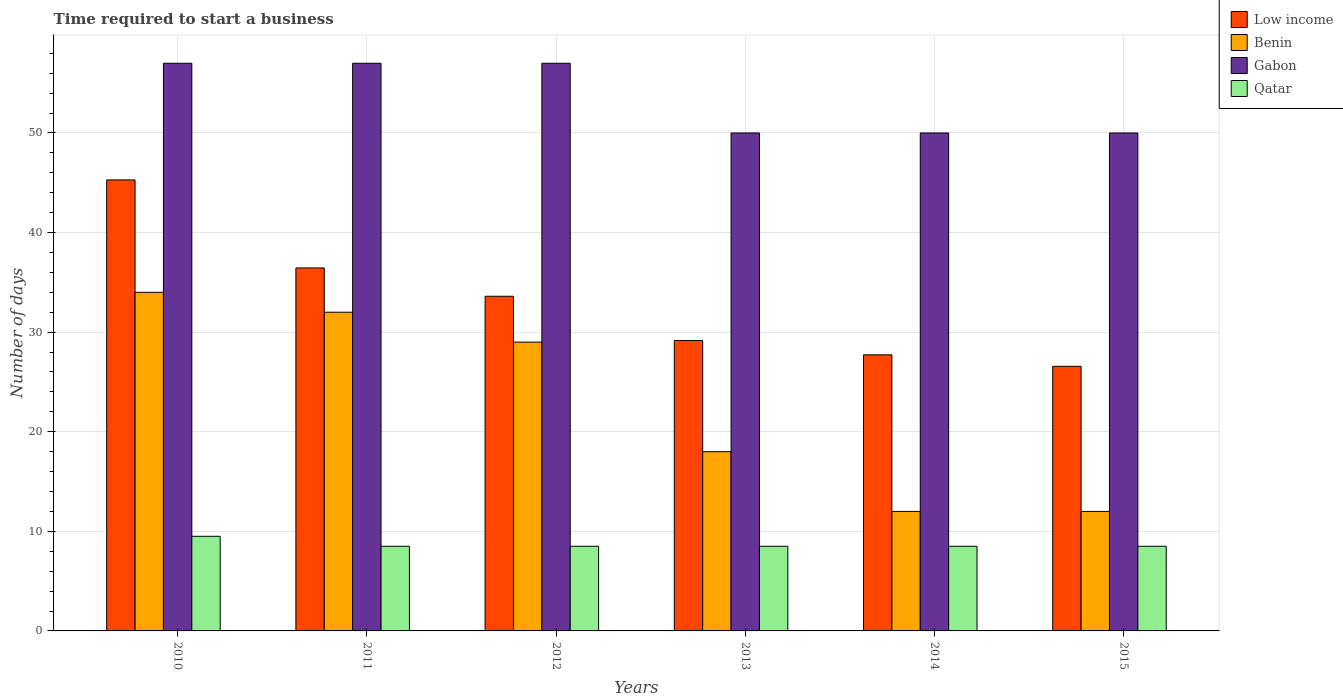How many different coloured bars are there?
Offer a very short reply. 4. Are the number of bars per tick equal to the number of legend labels?
Provide a succinct answer. Yes. Are the number of bars on each tick of the X-axis equal?
Offer a very short reply. Yes. How many bars are there on the 3rd tick from the left?
Keep it short and to the point. 4. What is the label of the 3rd group of bars from the left?
Ensure brevity in your answer.  2012. In how many cases, is the number of bars for a given year not equal to the number of legend labels?
Make the answer very short. 0. What is the number of days required to start a business in Qatar in 2012?
Make the answer very short. 8.5. Across all years, what is the maximum number of days required to start a business in Gabon?
Give a very brief answer. 57. Across all years, what is the minimum number of days required to start a business in Qatar?
Ensure brevity in your answer.  8.5. What is the total number of days required to start a business in Gabon in the graph?
Offer a terse response. 321. What is the difference between the number of days required to start a business in Gabon in 2011 and the number of days required to start a business in Qatar in 2010?
Keep it short and to the point. 47.5. What is the average number of days required to start a business in Gabon per year?
Your answer should be compact. 53.5. In the year 2012, what is the difference between the number of days required to start a business in Low income and number of days required to start a business in Benin?
Your answer should be compact. 4.6. What is the ratio of the number of days required to start a business in Qatar in 2010 to that in 2011?
Your response must be concise. 1.12. Is the number of days required to start a business in Qatar in 2011 less than that in 2014?
Ensure brevity in your answer.  No. Is the difference between the number of days required to start a business in Low income in 2011 and 2015 greater than the difference between the number of days required to start a business in Benin in 2011 and 2015?
Your answer should be very brief. No. What is the difference between the highest and the lowest number of days required to start a business in Benin?
Make the answer very short. 22. Is the sum of the number of days required to start a business in Gabon in 2010 and 2013 greater than the maximum number of days required to start a business in Benin across all years?
Your answer should be very brief. Yes. What does the 2nd bar from the left in 2011 represents?
Provide a succinct answer. Benin. What does the 2nd bar from the right in 2014 represents?
Make the answer very short. Gabon. Is it the case that in every year, the sum of the number of days required to start a business in Benin and number of days required to start a business in Low income is greater than the number of days required to start a business in Gabon?
Give a very brief answer. No. How many years are there in the graph?
Provide a short and direct response. 6. Are the values on the major ticks of Y-axis written in scientific E-notation?
Offer a terse response. No. Does the graph contain any zero values?
Make the answer very short. No. Does the graph contain grids?
Make the answer very short. Yes. Where does the legend appear in the graph?
Your answer should be very brief. Top right. How are the legend labels stacked?
Offer a very short reply. Vertical. What is the title of the graph?
Make the answer very short. Time required to start a business. What is the label or title of the Y-axis?
Ensure brevity in your answer.  Number of days. What is the Number of days of Low income in 2010?
Your answer should be compact. 45.29. What is the Number of days of Qatar in 2010?
Give a very brief answer. 9.5. What is the Number of days of Low income in 2011?
Give a very brief answer. 36.45. What is the Number of days in Benin in 2011?
Offer a very short reply. 32. What is the Number of days of Qatar in 2011?
Your answer should be very brief. 8.5. What is the Number of days in Low income in 2012?
Make the answer very short. 33.6. What is the Number of days of Qatar in 2012?
Ensure brevity in your answer.  8.5. What is the Number of days of Low income in 2013?
Give a very brief answer. 29.16. What is the Number of days in Benin in 2013?
Your response must be concise. 18. What is the Number of days of Gabon in 2013?
Your response must be concise. 50. What is the Number of days in Low income in 2014?
Your answer should be very brief. 27.72. What is the Number of days in Benin in 2014?
Your answer should be compact. 12. What is the Number of days in Gabon in 2014?
Your answer should be very brief. 50. What is the Number of days of Qatar in 2014?
Provide a succinct answer. 8.5. What is the Number of days of Low income in 2015?
Offer a very short reply. 26.57. What is the Number of days of Benin in 2015?
Your answer should be compact. 12. What is the Number of days of Gabon in 2015?
Keep it short and to the point. 50. What is the Number of days of Qatar in 2015?
Your answer should be compact. 8.5. Across all years, what is the maximum Number of days in Low income?
Your answer should be compact. 45.29. Across all years, what is the maximum Number of days of Gabon?
Your response must be concise. 57. Across all years, what is the maximum Number of days in Qatar?
Make the answer very short. 9.5. Across all years, what is the minimum Number of days of Low income?
Your answer should be compact. 26.57. Across all years, what is the minimum Number of days of Benin?
Make the answer very short. 12. What is the total Number of days in Low income in the graph?
Make the answer very short. 198.78. What is the total Number of days of Benin in the graph?
Your response must be concise. 137. What is the total Number of days of Gabon in the graph?
Offer a very short reply. 321. What is the difference between the Number of days of Low income in 2010 and that in 2011?
Offer a very short reply. 8.84. What is the difference between the Number of days of Gabon in 2010 and that in 2011?
Your answer should be very brief. 0. What is the difference between the Number of days of Low income in 2010 and that in 2012?
Your answer should be compact. 11.68. What is the difference between the Number of days of Benin in 2010 and that in 2012?
Give a very brief answer. 5. What is the difference between the Number of days in Gabon in 2010 and that in 2012?
Provide a succinct answer. 0. What is the difference between the Number of days in Low income in 2010 and that in 2013?
Keep it short and to the point. 16.13. What is the difference between the Number of days of Low income in 2010 and that in 2014?
Keep it short and to the point. 17.56. What is the difference between the Number of days of Low income in 2010 and that in 2015?
Your answer should be compact. 18.72. What is the difference between the Number of days of Benin in 2010 and that in 2015?
Ensure brevity in your answer.  22. What is the difference between the Number of days of Gabon in 2010 and that in 2015?
Provide a succinct answer. 7. What is the difference between the Number of days in Qatar in 2010 and that in 2015?
Provide a short and direct response. 1. What is the difference between the Number of days of Low income in 2011 and that in 2012?
Provide a succinct answer. 2.84. What is the difference between the Number of days of Benin in 2011 and that in 2012?
Offer a terse response. 3. What is the difference between the Number of days of Qatar in 2011 and that in 2012?
Provide a succinct answer. 0. What is the difference between the Number of days of Low income in 2011 and that in 2013?
Offer a very short reply. 7.29. What is the difference between the Number of days in Gabon in 2011 and that in 2013?
Offer a very short reply. 7. What is the difference between the Number of days in Low income in 2011 and that in 2014?
Provide a succinct answer. 8.72. What is the difference between the Number of days of Qatar in 2011 and that in 2014?
Your response must be concise. 0. What is the difference between the Number of days in Low income in 2011 and that in 2015?
Your response must be concise. 9.88. What is the difference between the Number of days of Benin in 2011 and that in 2015?
Keep it short and to the point. 20. What is the difference between the Number of days in Low income in 2012 and that in 2013?
Ensure brevity in your answer.  4.45. What is the difference between the Number of days of Gabon in 2012 and that in 2013?
Offer a very short reply. 7. What is the difference between the Number of days of Low income in 2012 and that in 2014?
Provide a succinct answer. 5.88. What is the difference between the Number of days of Benin in 2012 and that in 2014?
Ensure brevity in your answer.  17. What is the difference between the Number of days of Low income in 2012 and that in 2015?
Provide a succinct answer. 7.03. What is the difference between the Number of days of Low income in 2013 and that in 2014?
Ensure brevity in your answer.  1.43. What is the difference between the Number of days in Gabon in 2013 and that in 2014?
Give a very brief answer. 0. What is the difference between the Number of days of Low income in 2013 and that in 2015?
Give a very brief answer. 2.59. What is the difference between the Number of days of Gabon in 2013 and that in 2015?
Ensure brevity in your answer.  0. What is the difference between the Number of days in Low income in 2014 and that in 2015?
Provide a short and direct response. 1.16. What is the difference between the Number of days of Benin in 2014 and that in 2015?
Keep it short and to the point. 0. What is the difference between the Number of days in Qatar in 2014 and that in 2015?
Your response must be concise. 0. What is the difference between the Number of days of Low income in 2010 and the Number of days of Benin in 2011?
Your answer should be compact. 13.29. What is the difference between the Number of days in Low income in 2010 and the Number of days in Gabon in 2011?
Your answer should be compact. -11.71. What is the difference between the Number of days in Low income in 2010 and the Number of days in Qatar in 2011?
Ensure brevity in your answer.  36.79. What is the difference between the Number of days in Benin in 2010 and the Number of days in Qatar in 2011?
Your answer should be compact. 25.5. What is the difference between the Number of days of Gabon in 2010 and the Number of days of Qatar in 2011?
Your response must be concise. 48.5. What is the difference between the Number of days of Low income in 2010 and the Number of days of Benin in 2012?
Offer a very short reply. 16.29. What is the difference between the Number of days of Low income in 2010 and the Number of days of Gabon in 2012?
Give a very brief answer. -11.71. What is the difference between the Number of days of Low income in 2010 and the Number of days of Qatar in 2012?
Your response must be concise. 36.79. What is the difference between the Number of days in Benin in 2010 and the Number of days in Gabon in 2012?
Make the answer very short. -23. What is the difference between the Number of days in Gabon in 2010 and the Number of days in Qatar in 2012?
Provide a succinct answer. 48.5. What is the difference between the Number of days of Low income in 2010 and the Number of days of Benin in 2013?
Ensure brevity in your answer.  27.29. What is the difference between the Number of days in Low income in 2010 and the Number of days in Gabon in 2013?
Ensure brevity in your answer.  -4.71. What is the difference between the Number of days of Low income in 2010 and the Number of days of Qatar in 2013?
Provide a short and direct response. 36.79. What is the difference between the Number of days of Benin in 2010 and the Number of days of Gabon in 2013?
Keep it short and to the point. -16. What is the difference between the Number of days of Gabon in 2010 and the Number of days of Qatar in 2013?
Give a very brief answer. 48.5. What is the difference between the Number of days of Low income in 2010 and the Number of days of Benin in 2014?
Give a very brief answer. 33.29. What is the difference between the Number of days in Low income in 2010 and the Number of days in Gabon in 2014?
Your response must be concise. -4.71. What is the difference between the Number of days of Low income in 2010 and the Number of days of Qatar in 2014?
Keep it short and to the point. 36.79. What is the difference between the Number of days of Benin in 2010 and the Number of days of Gabon in 2014?
Your response must be concise. -16. What is the difference between the Number of days of Gabon in 2010 and the Number of days of Qatar in 2014?
Give a very brief answer. 48.5. What is the difference between the Number of days in Low income in 2010 and the Number of days in Benin in 2015?
Your answer should be very brief. 33.29. What is the difference between the Number of days of Low income in 2010 and the Number of days of Gabon in 2015?
Ensure brevity in your answer.  -4.71. What is the difference between the Number of days in Low income in 2010 and the Number of days in Qatar in 2015?
Your answer should be compact. 36.79. What is the difference between the Number of days in Gabon in 2010 and the Number of days in Qatar in 2015?
Keep it short and to the point. 48.5. What is the difference between the Number of days in Low income in 2011 and the Number of days in Benin in 2012?
Your answer should be very brief. 7.45. What is the difference between the Number of days of Low income in 2011 and the Number of days of Gabon in 2012?
Give a very brief answer. -20.55. What is the difference between the Number of days in Low income in 2011 and the Number of days in Qatar in 2012?
Ensure brevity in your answer.  27.95. What is the difference between the Number of days in Benin in 2011 and the Number of days in Qatar in 2012?
Give a very brief answer. 23.5. What is the difference between the Number of days in Gabon in 2011 and the Number of days in Qatar in 2012?
Offer a very short reply. 48.5. What is the difference between the Number of days in Low income in 2011 and the Number of days in Benin in 2013?
Offer a very short reply. 18.45. What is the difference between the Number of days in Low income in 2011 and the Number of days in Gabon in 2013?
Your answer should be very brief. -13.55. What is the difference between the Number of days in Low income in 2011 and the Number of days in Qatar in 2013?
Provide a short and direct response. 27.95. What is the difference between the Number of days of Gabon in 2011 and the Number of days of Qatar in 2013?
Ensure brevity in your answer.  48.5. What is the difference between the Number of days of Low income in 2011 and the Number of days of Benin in 2014?
Make the answer very short. 24.45. What is the difference between the Number of days in Low income in 2011 and the Number of days in Gabon in 2014?
Your response must be concise. -13.55. What is the difference between the Number of days of Low income in 2011 and the Number of days of Qatar in 2014?
Provide a succinct answer. 27.95. What is the difference between the Number of days of Benin in 2011 and the Number of days of Qatar in 2014?
Offer a very short reply. 23.5. What is the difference between the Number of days in Gabon in 2011 and the Number of days in Qatar in 2014?
Your answer should be compact. 48.5. What is the difference between the Number of days in Low income in 2011 and the Number of days in Benin in 2015?
Give a very brief answer. 24.45. What is the difference between the Number of days of Low income in 2011 and the Number of days of Gabon in 2015?
Keep it short and to the point. -13.55. What is the difference between the Number of days of Low income in 2011 and the Number of days of Qatar in 2015?
Your answer should be very brief. 27.95. What is the difference between the Number of days of Benin in 2011 and the Number of days of Gabon in 2015?
Provide a short and direct response. -18. What is the difference between the Number of days in Gabon in 2011 and the Number of days in Qatar in 2015?
Your answer should be very brief. 48.5. What is the difference between the Number of days in Low income in 2012 and the Number of days in Benin in 2013?
Make the answer very short. 15.6. What is the difference between the Number of days of Low income in 2012 and the Number of days of Gabon in 2013?
Your answer should be very brief. -16.4. What is the difference between the Number of days in Low income in 2012 and the Number of days in Qatar in 2013?
Make the answer very short. 25.1. What is the difference between the Number of days in Benin in 2012 and the Number of days in Gabon in 2013?
Give a very brief answer. -21. What is the difference between the Number of days of Gabon in 2012 and the Number of days of Qatar in 2013?
Offer a very short reply. 48.5. What is the difference between the Number of days of Low income in 2012 and the Number of days of Benin in 2014?
Keep it short and to the point. 21.6. What is the difference between the Number of days in Low income in 2012 and the Number of days in Gabon in 2014?
Provide a short and direct response. -16.4. What is the difference between the Number of days in Low income in 2012 and the Number of days in Qatar in 2014?
Offer a very short reply. 25.1. What is the difference between the Number of days of Benin in 2012 and the Number of days of Qatar in 2014?
Provide a succinct answer. 20.5. What is the difference between the Number of days in Gabon in 2012 and the Number of days in Qatar in 2014?
Ensure brevity in your answer.  48.5. What is the difference between the Number of days in Low income in 2012 and the Number of days in Benin in 2015?
Provide a short and direct response. 21.6. What is the difference between the Number of days of Low income in 2012 and the Number of days of Gabon in 2015?
Offer a very short reply. -16.4. What is the difference between the Number of days in Low income in 2012 and the Number of days in Qatar in 2015?
Make the answer very short. 25.1. What is the difference between the Number of days in Benin in 2012 and the Number of days in Gabon in 2015?
Ensure brevity in your answer.  -21. What is the difference between the Number of days in Gabon in 2012 and the Number of days in Qatar in 2015?
Provide a succinct answer. 48.5. What is the difference between the Number of days in Low income in 2013 and the Number of days in Benin in 2014?
Your answer should be very brief. 17.16. What is the difference between the Number of days of Low income in 2013 and the Number of days of Gabon in 2014?
Give a very brief answer. -20.84. What is the difference between the Number of days of Low income in 2013 and the Number of days of Qatar in 2014?
Your answer should be very brief. 20.66. What is the difference between the Number of days in Benin in 2013 and the Number of days in Gabon in 2014?
Provide a succinct answer. -32. What is the difference between the Number of days of Benin in 2013 and the Number of days of Qatar in 2014?
Your response must be concise. 9.5. What is the difference between the Number of days in Gabon in 2013 and the Number of days in Qatar in 2014?
Ensure brevity in your answer.  41.5. What is the difference between the Number of days in Low income in 2013 and the Number of days in Benin in 2015?
Provide a succinct answer. 17.16. What is the difference between the Number of days in Low income in 2013 and the Number of days in Gabon in 2015?
Your answer should be compact. -20.84. What is the difference between the Number of days in Low income in 2013 and the Number of days in Qatar in 2015?
Keep it short and to the point. 20.66. What is the difference between the Number of days in Benin in 2013 and the Number of days in Gabon in 2015?
Keep it short and to the point. -32. What is the difference between the Number of days in Gabon in 2013 and the Number of days in Qatar in 2015?
Ensure brevity in your answer.  41.5. What is the difference between the Number of days in Low income in 2014 and the Number of days in Benin in 2015?
Provide a succinct answer. 15.72. What is the difference between the Number of days of Low income in 2014 and the Number of days of Gabon in 2015?
Keep it short and to the point. -22.28. What is the difference between the Number of days of Low income in 2014 and the Number of days of Qatar in 2015?
Your answer should be compact. 19.22. What is the difference between the Number of days in Benin in 2014 and the Number of days in Gabon in 2015?
Ensure brevity in your answer.  -38. What is the difference between the Number of days of Benin in 2014 and the Number of days of Qatar in 2015?
Make the answer very short. 3.5. What is the difference between the Number of days of Gabon in 2014 and the Number of days of Qatar in 2015?
Your answer should be compact. 41.5. What is the average Number of days of Low income per year?
Your answer should be compact. 33.13. What is the average Number of days in Benin per year?
Provide a succinct answer. 22.83. What is the average Number of days of Gabon per year?
Your answer should be compact. 53.5. What is the average Number of days of Qatar per year?
Your answer should be compact. 8.67. In the year 2010, what is the difference between the Number of days in Low income and Number of days in Benin?
Offer a very short reply. 11.29. In the year 2010, what is the difference between the Number of days in Low income and Number of days in Gabon?
Give a very brief answer. -11.71. In the year 2010, what is the difference between the Number of days of Low income and Number of days of Qatar?
Offer a very short reply. 35.79. In the year 2010, what is the difference between the Number of days in Benin and Number of days in Qatar?
Provide a succinct answer. 24.5. In the year 2010, what is the difference between the Number of days of Gabon and Number of days of Qatar?
Keep it short and to the point. 47.5. In the year 2011, what is the difference between the Number of days of Low income and Number of days of Benin?
Your response must be concise. 4.45. In the year 2011, what is the difference between the Number of days of Low income and Number of days of Gabon?
Make the answer very short. -20.55. In the year 2011, what is the difference between the Number of days in Low income and Number of days in Qatar?
Your answer should be very brief. 27.95. In the year 2011, what is the difference between the Number of days in Benin and Number of days in Gabon?
Your answer should be compact. -25. In the year 2011, what is the difference between the Number of days of Gabon and Number of days of Qatar?
Ensure brevity in your answer.  48.5. In the year 2012, what is the difference between the Number of days of Low income and Number of days of Benin?
Offer a terse response. 4.6. In the year 2012, what is the difference between the Number of days in Low income and Number of days in Gabon?
Your answer should be compact. -23.4. In the year 2012, what is the difference between the Number of days of Low income and Number of days of Qatar?
Provide a short and direct response. 25.1. In the year 2012, what is the difference between the Number of days in Benin and Number of days in Gabon?
Make the answer very short. -28. In the year 2012, what is the difference between the Number of days in Benin and Number of days in Qatar?
Offer a terse response. 20.5. In the year 2012, what is the difference between the Number of days in Gabon and Number of days in Qatar?
Ensure brevity in your answer.  48.5. In the year 2013, what is the difference between the Number of days of Low income and Number of days of Benin?
Ensure brevity in your answer.  11.16. In the year 2013, what is the difference between the Number of days of Low income and Number of days of Gabon?
Offer a very short reply. -20.84. In the year 2013, what is the difference between the Number of days of Low income and Number of days of Qatar?
Ensure brevity in your answer.  20.66. In the year 2013, what is the difference between the Number of days in Benin and Number of days in Gabon?
Keep it short and to the point. -32. In the year 2013, what is the difference between the Number of days in Benin and Number of days in Qatar?
Offer a terse response. 9.5. In the year 2013, what is the difference between the Number of days in Gabon and Number of days in Qatar?
Give a very brief answer. 41.5. In the year 2014, what is the difference between the Number of days in Low income and Number of days in Benin?
Your answer should be very brief. 15.72. In the year 2014, what is the difference between the Number of days of Low income and Number of days of Gabon?
Provide a short and direct response. -22.28. In the year 2014, what is the difference between the Number of days of Low income and Number of days of Qatar?
Your answer should be compact. 19.22. In the year 2014, what is the difference between the Number of days in Benin and Number of days in Gabon?
Give a very brief answer. -38. In the year 2014, what is the difference between the Number of days of Gabon and Number of days of Qatar?
Offer a very short reply. 41.5. In the year 2015, what is the difference between the Number of days in Low income and Number of days in Benin?
Make the answer very short. 14.57. In the year 2015, what is the difference between the Number of days of Low income and Number of days of Gabon?
Make the answer very short. -23.43. In the year 2015, what is the difference between the Number of days of Low income and Number of days of Qatar?
Provide a short and direct response. 18.07. In the year 2015, what is the difference between the Number of days in Benin and Number of days in Gabon?
Ensure brevity in your answer.  -38. In the year 2015, what is the difference between the Number of days in Benin and Number of days in Qatar?
Your answer should be compact. 3.5. In the year 2015, what is the difference between the Number of days of Gabon and Number of days of Qatar?
Give a very brief answer. 41.5. What is the ratio of the Number of days of Low income in 2010 to that in 2011?
Ensure brevity in your answer.  1.24. What is the ratio of the Number of days in Benin in 2010 to that in 2011?
Provide a succinct answer. 1.06. What is the ratio of the Number of days in Qatar in 2010 to that in 2011?
Provide a short and direct response. 1.12. What is the ratio of the Number of days of Low income in 2010 to that in 2012?
Give a very brief answer. 1.35. What is the ratio of the Number of days of Benin in 2010 to that in 2012?
Offer a terse response. 1.17. What is the ratio of the Number of days of Gabon in 2010 to that in 2012?
Provide a short and direct response. 1. What is the ratio of the Number of days of Qatar in 2010 to that in 2012?
Provide a short and direct response. 1.12. What is the ratio of the Number of days of Low income in 2010 to that in 2013?
Ensure brevity in your answer.  1.55. What is the ratio of the Number of days of Benin in 2010 to that in 2013?
Your answer should be compact. 1.89. What is the ratio of the Number of days in Gabon in 2010 to that in 2013?
Ensure brevity in your answer.  1.14. What is the ratio of the Number of days of Qatar in 2010 to that in 2013?
Provide a succinct answer. 1.12. What is the ratio of the Number of days of Low income in 2010 to that in 2014?
Make the answer very short. 1.63. What is the ratio of the Number of days of Benin in 2010 to that in 2014?
Offer a very short reply. 2.83. What is the ratio of the Number of days of Gabon in 2010 to that in 2014?
Offer a terse response. 1.14. What is the ratio of the Number of days of Qatar in 2010 to that in 2014?
Provide a succinct answer. 1.12. What is the ratio of the Number of days of Low income in 2010 to that in 2015?
Make the answer very short. 1.7. What is the ratio of the Number of days of Benin in 2010 to that in 2015?
Keep it short and to the point. 2.83. What is the ratio of the Number of days in Gabon in 2010 to that in 2015?
Give a very brief answer. 1.14. What is the ratio of the Number of days in Qatar in 2010 to that in 2015?
Your answer should be very brief. 1.12. What is the ratio of the Number of days in Low income in 2011 to that in 2012?
Your answer should be compact. 1.08. What is the ratio of the Number of days of Benin in 2011 to that in 2012?
Offer a very short reply. 1.1. What is the ratio of the Number of days in Gabon in 2011 to that in 2012?
Give a very brief answer. 1. What is the ratio of the Number of days of Qatar in 2011 to that in 2012?
Ensure brevity in your answer.  1. What is the ratio of the Number of days of Low income in 2011 to that in 2013?
Make the answer very short. 1.25. What is the ratio of the Number of days in Benin in 2011 to that in 2013?
Keep it short and to the point. 1.78. What is the ratio of the Number of days of Gabon in 2011 to that in 2013?
Keep it short and to the point. 1.14. What is the ratio of the Number of days of Low income in 2011 to that in 2014?
Your response must be concise. 1.31. What is the ratio of the Number of days in Benin in 2011 to that in 2014?
Your response must be concise. 2.67. What is the ratio of the Number of days in Gabon in 2011 to that in 2014?
Offer a very short reply. 1.14. What is the ratio of the Number of days in Low income in 2011 to that in 2015?
Make the answer very short. 1.37. What is the ratio of the Number of days of Benin in 2011 to that in 2015?
Your response must be concise. 2.67. What is the ratio of the Number of days in Gabon in 2011 to that in 2015?
Provide a succinct answer. 1.14. What is the ratio of the Number of days in Qatar in 2011 to that in 2015?
Offer a very short reply. 1. What is the ratio of the Number of days of Low income in 2012 to that in 2013?
Provide a succinct answer. 1.15. What is the ratio of the Number of days in Benin in 2012 to that in 2013?
Provide a succinct answer. 1.61. What is the ratio of the Number of days of Gabon in 2012 to that in 2013?
Your answer should be compact. 1.14. What is the ratio of the Number of days of Low income in 2012 to that in 2014?
Your response must be concise. 1.21. What is the ratio of the Number of days of Benin in 2012 to that in 2014?
Ensure brevity in your answer.  2.42. What is the ratio of the Number of days in Gabon in 2012 to that in 2014?
Make the answer very short. 1.14. What is the ratio of the Number of days in Low income in 2012 to that in 2015?
Offer a very short reply. 1.26. What is the ratio of the Number of days of Benin in 2012 to that in 2015?
Provide a succinct answer. 2.42. What is the ratio of the Number of days in Gabon in 2012 to that in 2015?
Make the answer very short. 1.14. What is the ratio of the Number of days of Low income in 2013 to that in 2014?
Provide a short and direct response. 1.05. What is the ratio of the Number of days of Gabon in 2013 to that in 2014?
Provide a short and direct response. 1. What is the ratio of the Number of days in Low income in 2013 to that in 2015?
Your answer should be very brief. 1.1. What is the ratio of the Number of days of Benin in 2013 to that in 2015?
Keep it short and to the point. 1.5. What is the ratio of the Number of days of Gabon in 2013 to that in 2015?
Ensure brevity in your answer.  1. What is the ratio of the Number of days in Low income in 2014 to that in 2015?
Ensure brevity in your answer.  1.04. What is the ratio of the Number of days of Benin in 2014 to that in 2015?
Provide a short and direct response. 1. What is the ratio of the Number of days in Qatar in 2014 to that in 2015?
Make the answer very short. 1. What is the difference between the highest and the second highest Number of days in Low income?
Your answer should be very brief. 8.84. What is the difference between the highest and the lowest Number of days in Low income?
Your answer should be very brief. 18.72. What is the difference between the highest and the lowest Number of days in Qatar?
Give a very brief answer. 1. 